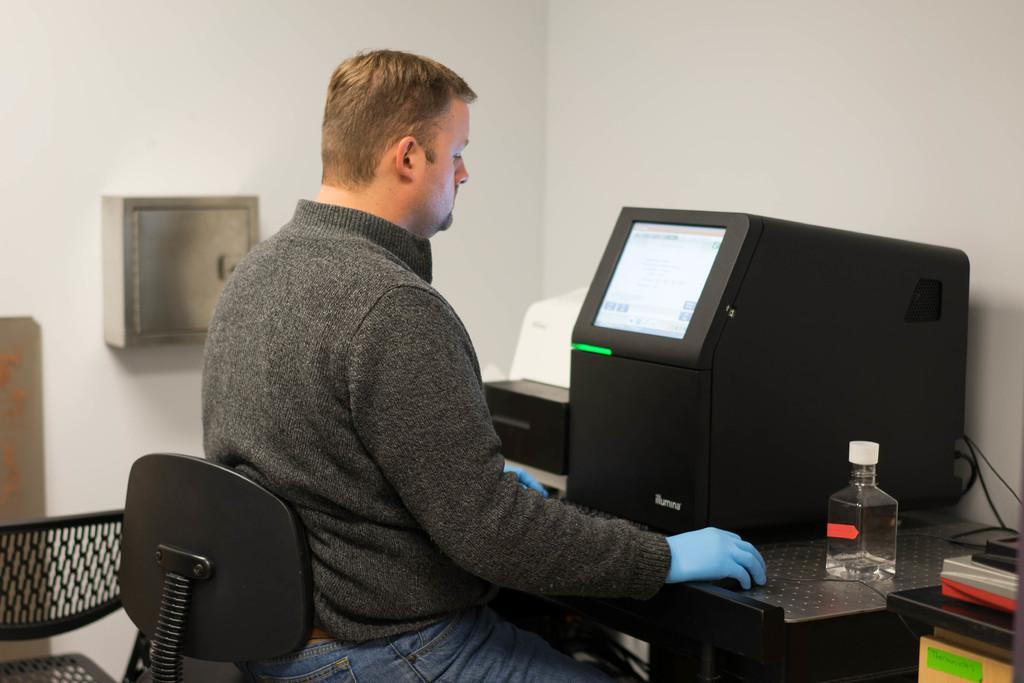Please provide a concise description of this image. In this picture there is a man who is wearing t-shirt, jeans and gloves. He is sitting on the chair. He is looking to this screen. On the table we can see a bottle, mouse, screen, printer and other objects. 